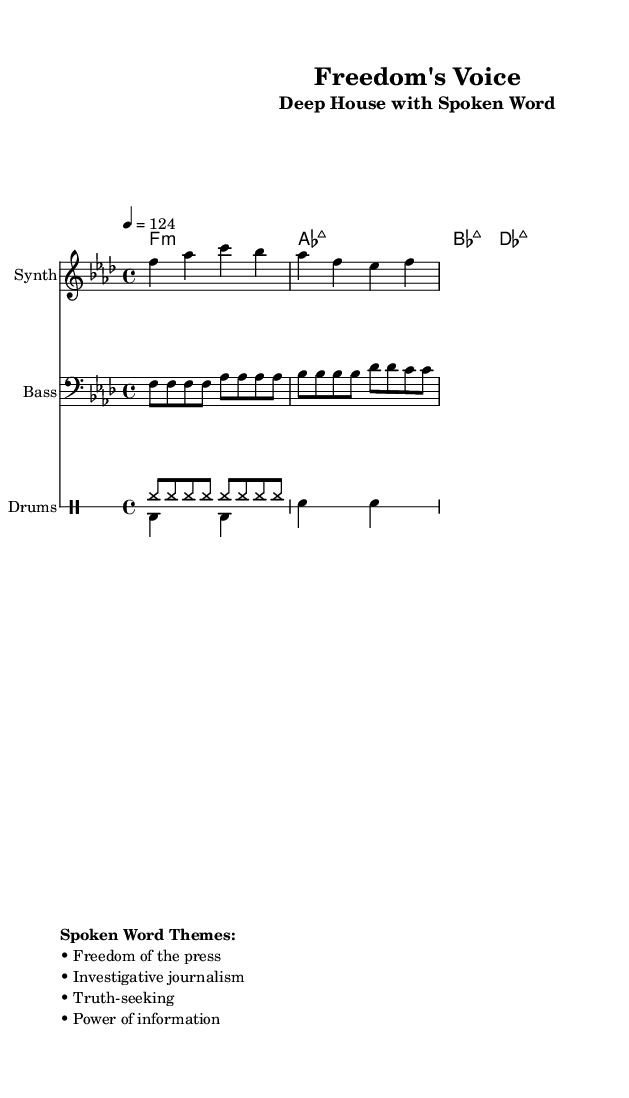What is the key signature of this music? The key signature is F minor, which contains four flats (B♭, E♭, A♭, D♭). This can be determined by examining the global settings at the beginning of the score.
Answer: F minor What is the time signature of this music? The time signature is 4/4, indicating there are four beats per measure and the quarter note receives one beat. This is stated in the global settings in the score.
Answer: 4/4 What is the tempo marking of this piece? The tempo marking is 124, which means the music is to be played at 124 beats per minute. This is specified in the global section of the sheet music.
Answer: 124 How many measures are there in the melody? There are four measures in the melody section, as indicated by the grouping of the notes written in the melody staff. Counting each grouping shows the measure divisions.
Answer: 4 What is the primary theme addressed in the spoken word section? The primary theme addressed is "Freedom of the press", as stated in the markup section of the music which highlights key themes of spoken word.
Answer: Freedom of the press Which instruments are present in this composition? The instruments present are Synth, Bass, and Drums, identified by their respective staff sections within the score layout.
Answer: Synth, Bass, Drums What type of drum pattern is indicated for the drums down section? The drum pattern for the drums down section consists of bass drum and snare drum hits, organized in alternating patterns of beats and rests, indicated in the drummode section.
Answer: Bass and snare 